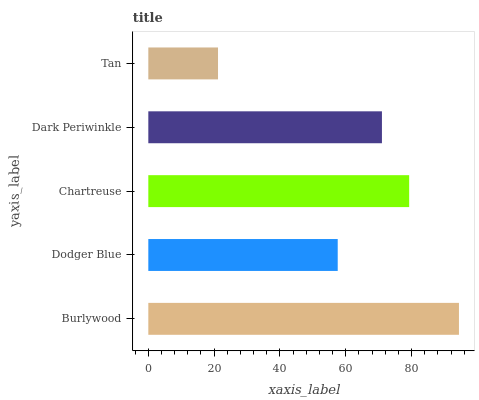Is Tan the minimum?
Answer yes or no. Yes. Is Burlywood the maximum?
Answer yes or no. Yes. Is Dodger Blue the minimum?
Answer yes or no. No. Is Dodger Blue the maximum?
Answer yes or no. No. Is Burlywood greater than Dodger Blue?
Answer yes or no. Yes. Is Dodger Blue less than Burlywood?
Answer yes or no. Yes. Is Dodger Blue greater than Burlywood?
Answer yes or no. No. Is Burlywood less than Dodger Blue?
Answer yes or no. No. Is Dark Periwinkle the high median?
Answer yes or no. Yes. Is Dark Periwinkle the low median?
Answer yes or no. Yes. Is Dodger Blue the high median?
Answer yes or no. No. Is Tan the low median?
Answer yes or no. No. 